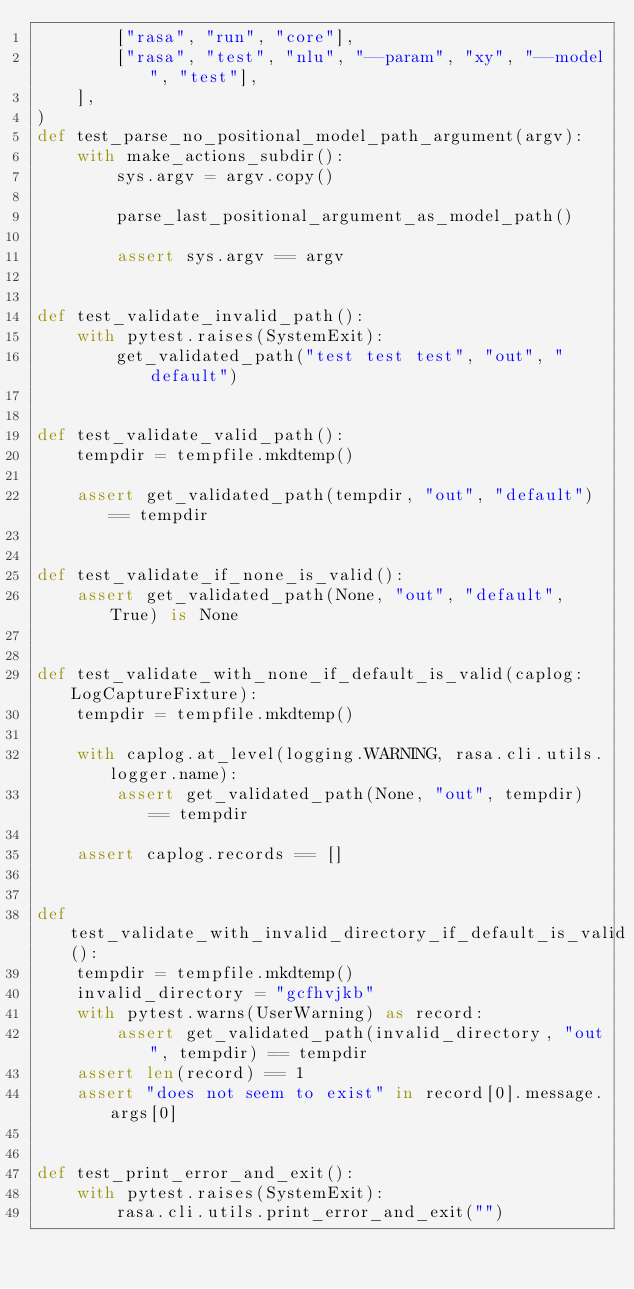Convert code to text. <code><loc_0><loc_0><loc_500><loc_500><_Python_>        ["rasa", "run", "core"],
        ["rasa", "test", "nlu", "--param", "xy", "--model", "test"],
    ],
)
def test_parse_no_positional_model_path_argument(argv):
    with make_actions_subdir():
        sys.argv = argv.copy()

        parse_last_positional_argument_as_model_path()

        assert sys.argv == argv


def test_validate_invalid_path():
    with pytest.raises(SystemExit):
        get_validated_path("test test test", "out", "default")


def test_validate_valid_path():
    tempdir = tempfile.mkdtemp()

    assert get_validated_path(tempdir, "out", "default") == tempdir


def test_validate_if_none_is_valid():
    assert get_validated_path(None, "out", "default", True) is None


def test_validate_with_none_if_default_is_valid(caplog: LogCaptureFixture):
    tempdir = tempfile.mkdtemp()

    with caplog.at_level(logging.WARNING, rasa.cli.utils.logger.name):
        assert get_validated_path(None, "out", tempdir) == tempdir

    assert caplog.records == []


def test_validate_with_invalid_directory_if_default_is_valid():
    tempdir = tempfile.mkdtemp()
    invalid_directory = "gcfhvjkb"
    with pytest.warns(UserWarning) as record:
        assert get_validated_path(invalid_directory, "out", tempdir) == tempdir
    assert len(record) == 1
    assert "does not seem to exist" in record[0].message.args[0]


def test_print_error_and_exit():
    with pytest.raises(SystemExit):
        rasa.cli.utils.print_error_and_exit("")
</code> 